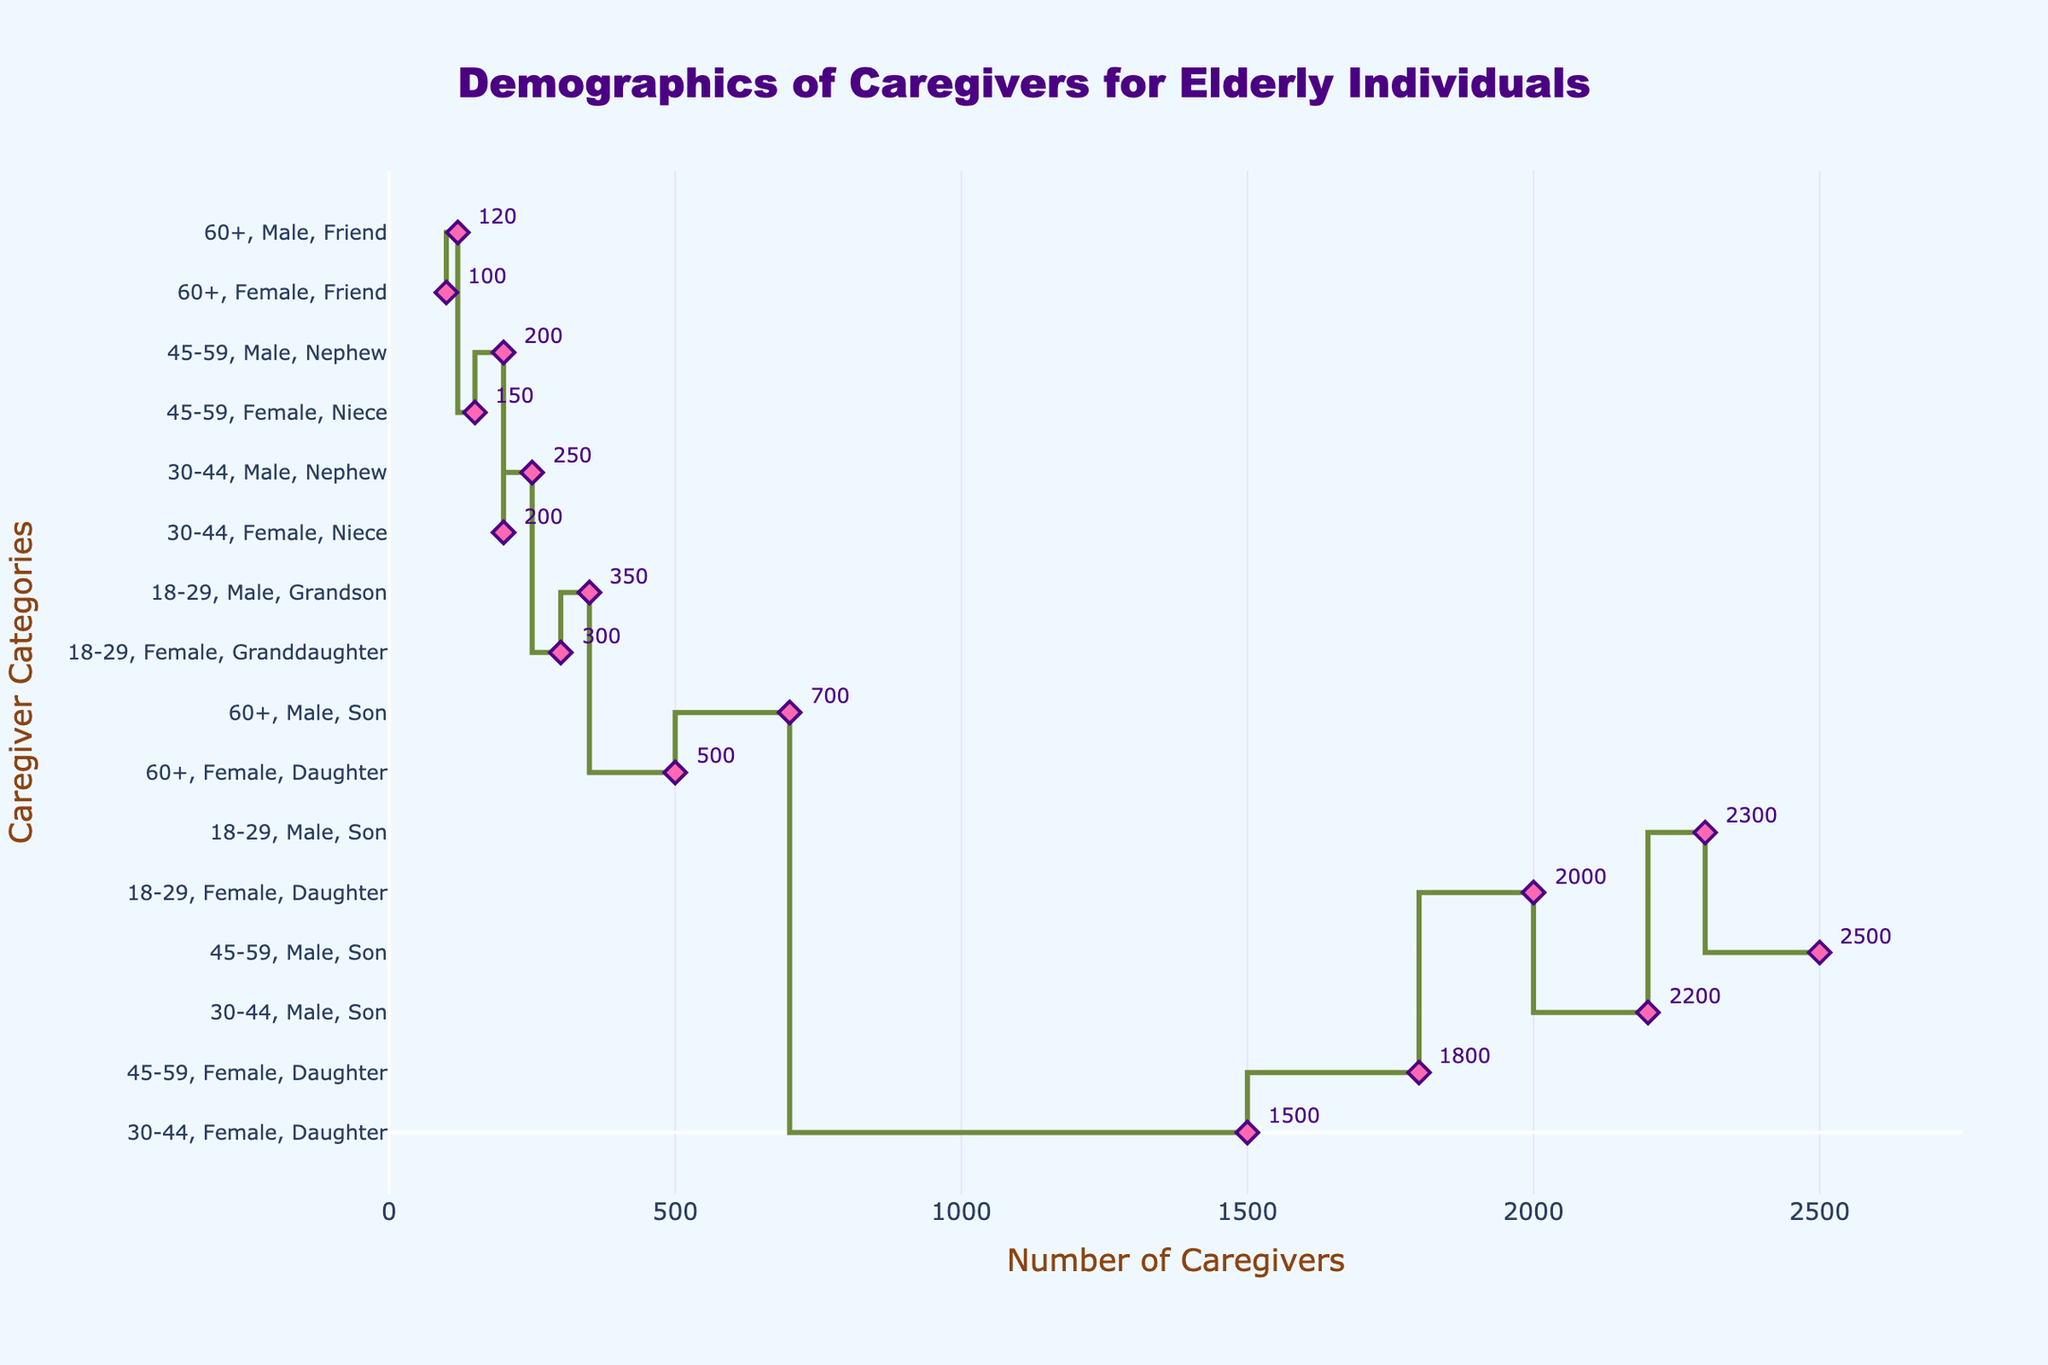What is the title of the plot? The title of the plot is positioned at the top center of the figure and is enclosed within a box. Upon observation, it reads "Demographics of Caregivers for Elderly Individuals".
Answer: Demographics of Caregivers for Elderly Individuals What is the age group with the highest number of caregivers? To find the age group with the highest number of caregivers, look at the x-axis and find the point with the highest value. Hover over the data points to read the associated text. The highest is reached by "30-44, Female, Daughter". This is the age group with the highest value, which is 2,500 caregivers.
Answer: 30-44 How many caregivers are sons aged 45-59? Look at the data points on the plot, and hover to identify text showing "45-59, Male, Son". The annotation shows the number of caregivers for this group as 2,000.
Answer: 2,000 Who has more caregivers: Granddaughters aged 18-29 or Friends aged 60+? Locate the points for "18-29, Female, Granddaughter" and "60+, Female, Friend". Hover over them to read the numbers: 350 for granddaughters and 120 for friends. Comparing these figures, granddaughters have more caregivers.
Answer: Granddaughters aged 18-29 What is the combined number of caregivers for nephews and nieces aged 30-44? Find the points for "30-44, Male, Nephew" and "30-44, Female, Niece". Their values are 200 and 250, respectively. Adding these values gives 200 + 250 = 450.
Answer: 450 Which gender has more caregivers in the 18-29 age group? Examine the plot points for "18-29, Male" and "18-29, Female". Sum the values for both sons (1,500), grandsons (300) which is 1,800 in total for males; and for daughters (1,800) and granddaughters (350), which total 2,150 for females. Females have more caregivers in this age group.
Answer: Female Is there a significant drop in the number of caregivers after the age of 60? Compare points before and after the "60+" age group. The highest values before 60 are around 2,500 and 2,300, while those after 60 are 500 and 700. The difference indicates a significant drop in the number of caregivers after age 60.
Answer: Yes Which relation is most common among caregivers aged 45-59? Look at the points for "45-59, Male, Son" and "45-59, Female, Daughter". These points have high numbers relative to others in the same age group, with 2,000 and 2,300 caregivers respectively. Thus, 'Daughter' is the most common relation.
Answer: Daughter 